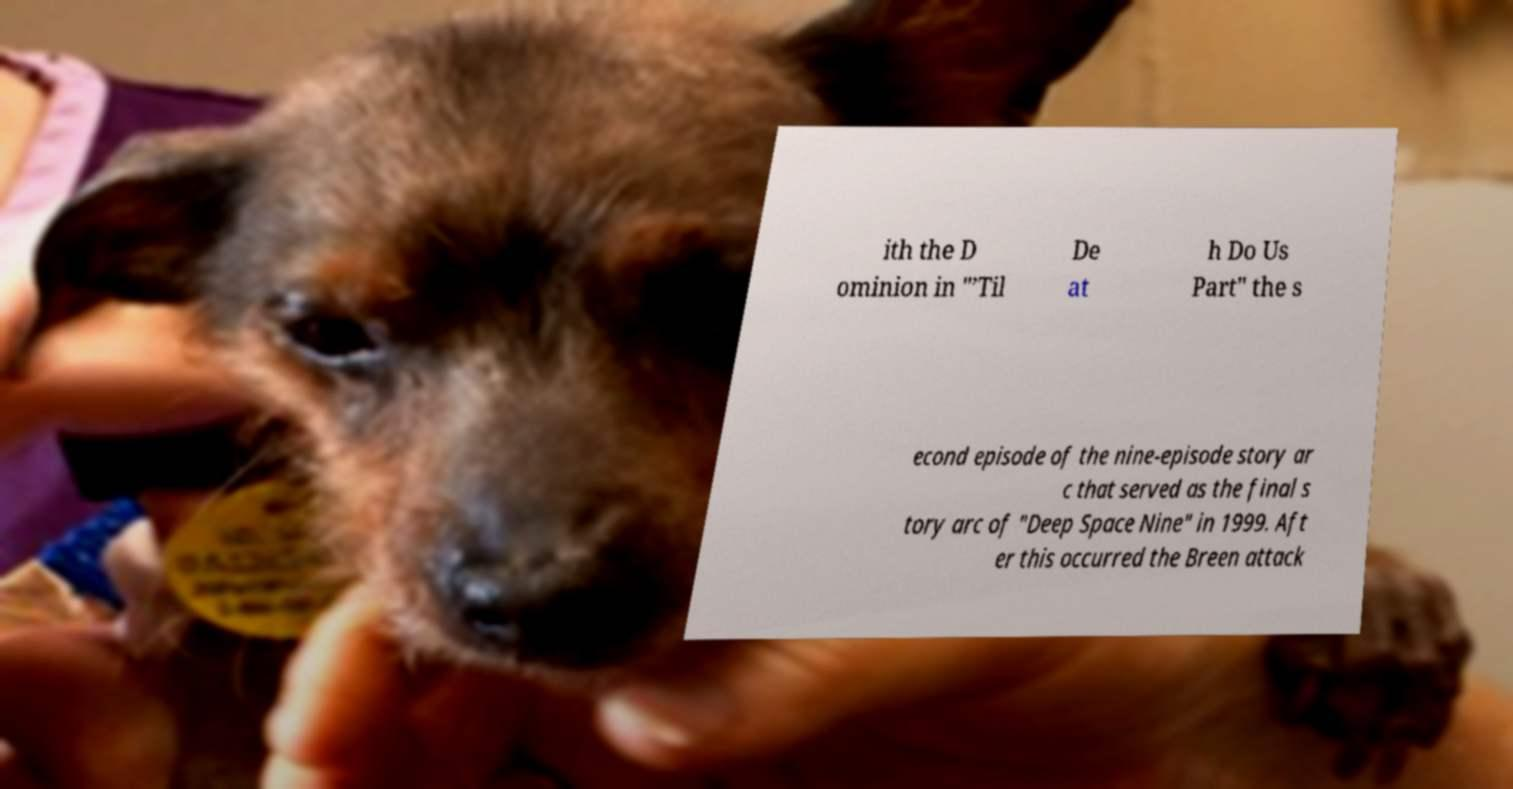Could you extract and type out the text from this image? ith the D ominion in "’Til De at h Do Us Part" the s econd episode of the nine-episode story ar c that served as the final s tory arc of "Deep Space Nine" in 1999. Aft er this occurred the Breen attack 